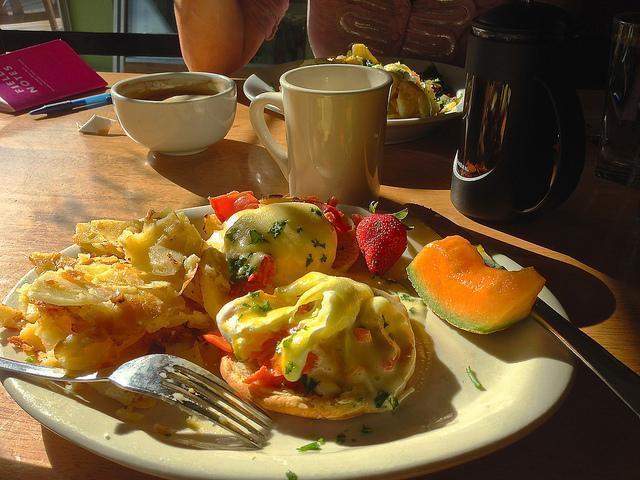How many bowls can be seen?
Give a very brief answer. 2. How many cups can you see?
Give a very brief answer. 3. How many trucks are there?
Give a very brief answer. 0. 